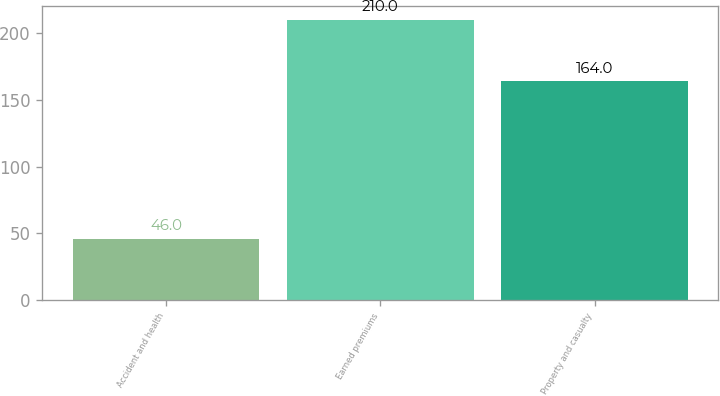Convert chart to OTSL. <chart><loc_0><loc_0><loc_500><loc_500><bar_chart><fcel>Accident and health<fcel>Earned premiums<fcel>Property and casualty<nl><fcel>46<fcel>210<fcel>164<nl></chart> 